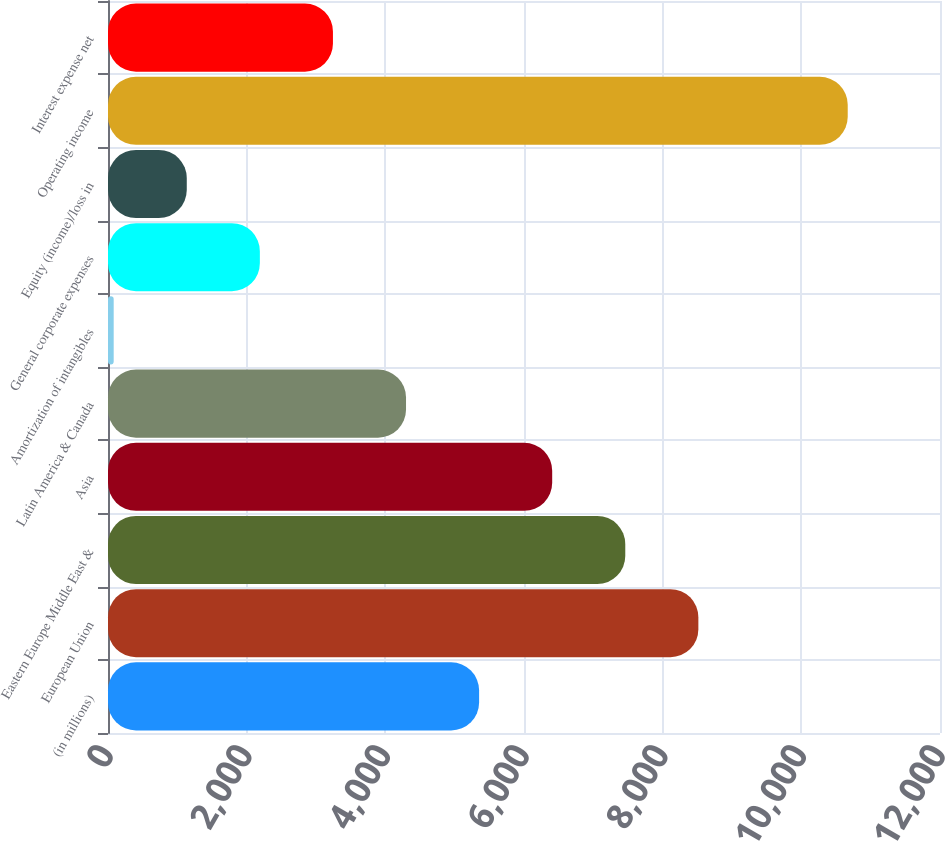<chart> <loc_0><loc_0><loc_500><loc_500><bar_chart><fcel>(in millions)<fcel>European Union<fcel>Eastern Europe Middle East &<fcel>Asia<fcel>Latin America & Canada<fcel>Amortization of intangibles<fcel>General corporate expenses<fcel>Equity (income)/loss in<fcel>Operating income<fcel>Interest expense net<nl><fcel>5352.5<fcel>8514.8<fcel>7460.7<fcel>6406.6<fcel>4298.4<fcel>82<fcel>2190.2<fcel>1136.1<fcel>10669.1<fcel>3244.3<nl></chart> 